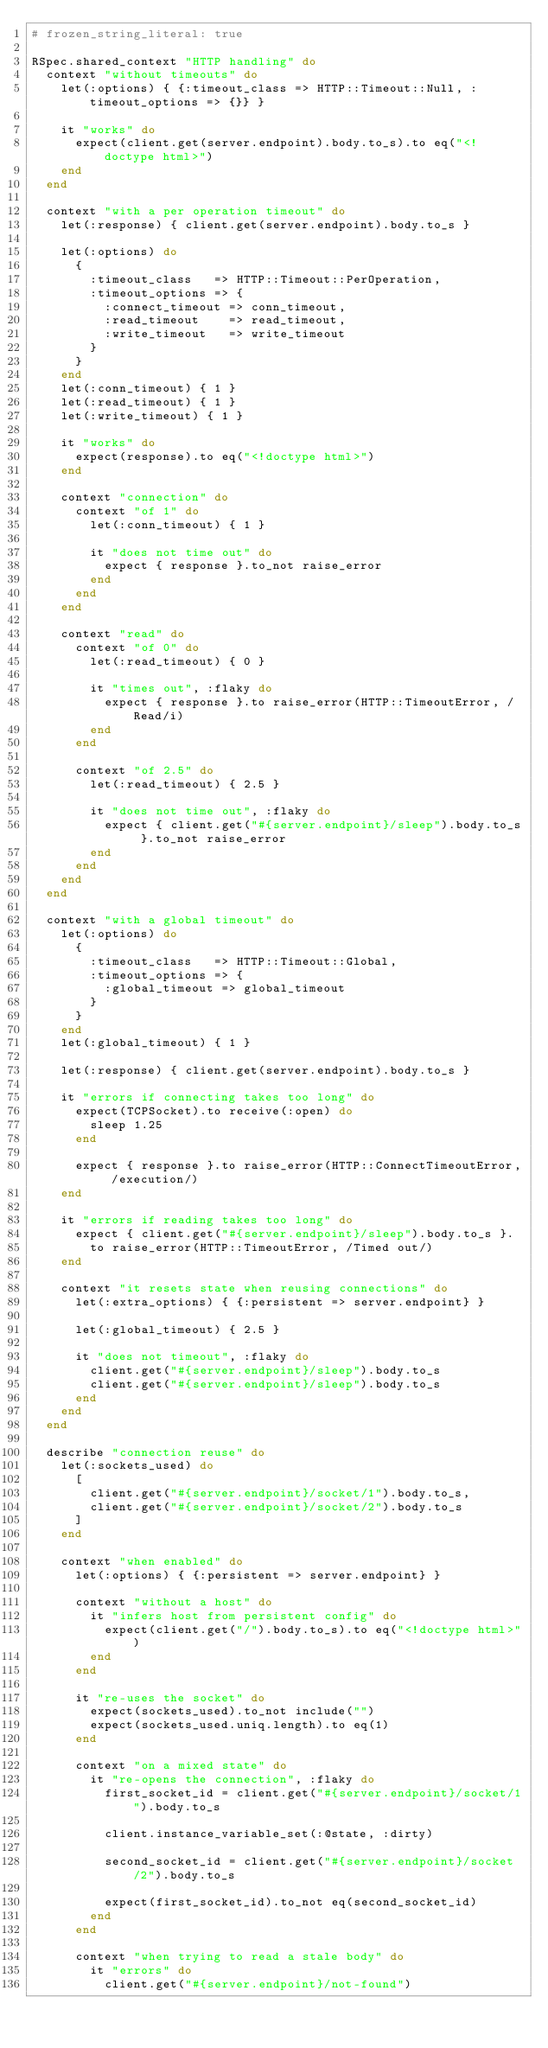<code> <loc_0><loc_0><loc_500><loc_500><_Ruby_># frozen_string_literal: true

RSpec.shared_context "HTTP handling" do
  context "without timeouts" do
    let(:options) { {:timeout_class => HTTP::Timeout::Null, :timeout_options => {}} }

    it "works" do
      expect(client.get(server.endpoint).body.to_s).to eq("<!doctype html>")
    end
  end

  context "with a per operation timeout" do
    let(:response) { client.get(server.endpoint).body.to_s }

    let(:options) do
      {
        :timeout_class   => HTTP::Timeout::PerOperation,
        :timeout_options => {
          :connect_timeout => conn_timeout,
          :read_timeout    => read_timeout,
          :write_timeout   => write_timeout
        }
      }
    end
    let(:conn_timeout) { 1 }
    let(:read_timeout) { 1 }
    let(:write_timeout) { 1 }

    it "works" do
      expect(response).to eq("<!doctype html>")
    end

    context "connection" do
      context "of 1" do
        let(:conn_timeout) { 1 }

        it "does not time out" do
          expect { response }.to_not raise_error
        end
      end
    end

    context "read" do
      context "of 0" do
        let(:read_timeout) { 0 }

        it "times out", :flaky do
          expect { response }.to raise_error(HTTP::TimeoutError, /Read/i)
        end
      end

      context "of 2.5" do
        let(:read_timeout) { 2.5 }

        it "does not time out", :flaky do
          expect { client.get("#{server.endpoint}/sleep").body.to_s }.to_not raise_error
        end
      end
    end
  end

  context "with a global timeout" do
    let(:options) do
      {
        :timeout_class   => HTTP::Timeout::Global,
        :timeout_options => {
          :global_timeout => global_timeout
        }
      }
    end
    let(:global_timeout) { 1 }

    let(:response) { client.get(server.endpoint).body.to_s }

    it "errors if connecting takes too long" do
      expect(TCPSocket).to receive(:open) do
        sleep 1.25
      end

      expect { response }.to raise_error(HTTP::ConnectTimeoutError, /execution/)
    end

    it "errors if reading takes too long" do
      expect { client.get("#{server.endpoint}/sleep").body.to_s }.
        to raise_error(HTTP::TimeoutError, /Timed out/)
    end

    context "it resets state when reusing connections" do
      let(:extra_options) { {:persistent => server.endpoint} }

      let(:global_timeout) { 2.5 }

      it "does not timeout", :flaky do
        client.get("#{server.endpoint}/sleep").body.to_s
        client.get("#{server.endpoint}/sleep").body.to_s
      end
    end
  end

  describe "connection reuse" do
    let(:sockets_used) do
      [
        client.get("#{server.endpoint}/socket/1").body.to_s,
        client.get("#{server.endpoint}/socket/2").body.to_s
      ]
    end

    context "when enabled" do
      let(:options) { {:persistent => server.endpoint} }

      context "without a host" do
        it "infers host from persistent config" do
          expect(client.get("/").body.to_s).to eq("<!doctype html>")
        end
      end

      it "re-uses the socket" do
        expect(sockets_used).to_not include("")
        expect(sockets_used.uniq.length).to eq(1)
      end

      context "on a mixed state" do
        it "re-opens the connection", :flaky do
          first_socket_id = client.get("#{server.endpoint}/socket/1").body.to_s

          client.instance_variable_set(:@state, :dirty)

          second_socket_id = client.get("#{server.endpoint}/socket/2").body.to_s

          expect(first_socket_id).to_not eq(second_socket_id)
        end
      end

      context "when trying to read a stale body" do
        it "errors" do
          client.get("#{server.endpoint}/not-found")</code> 